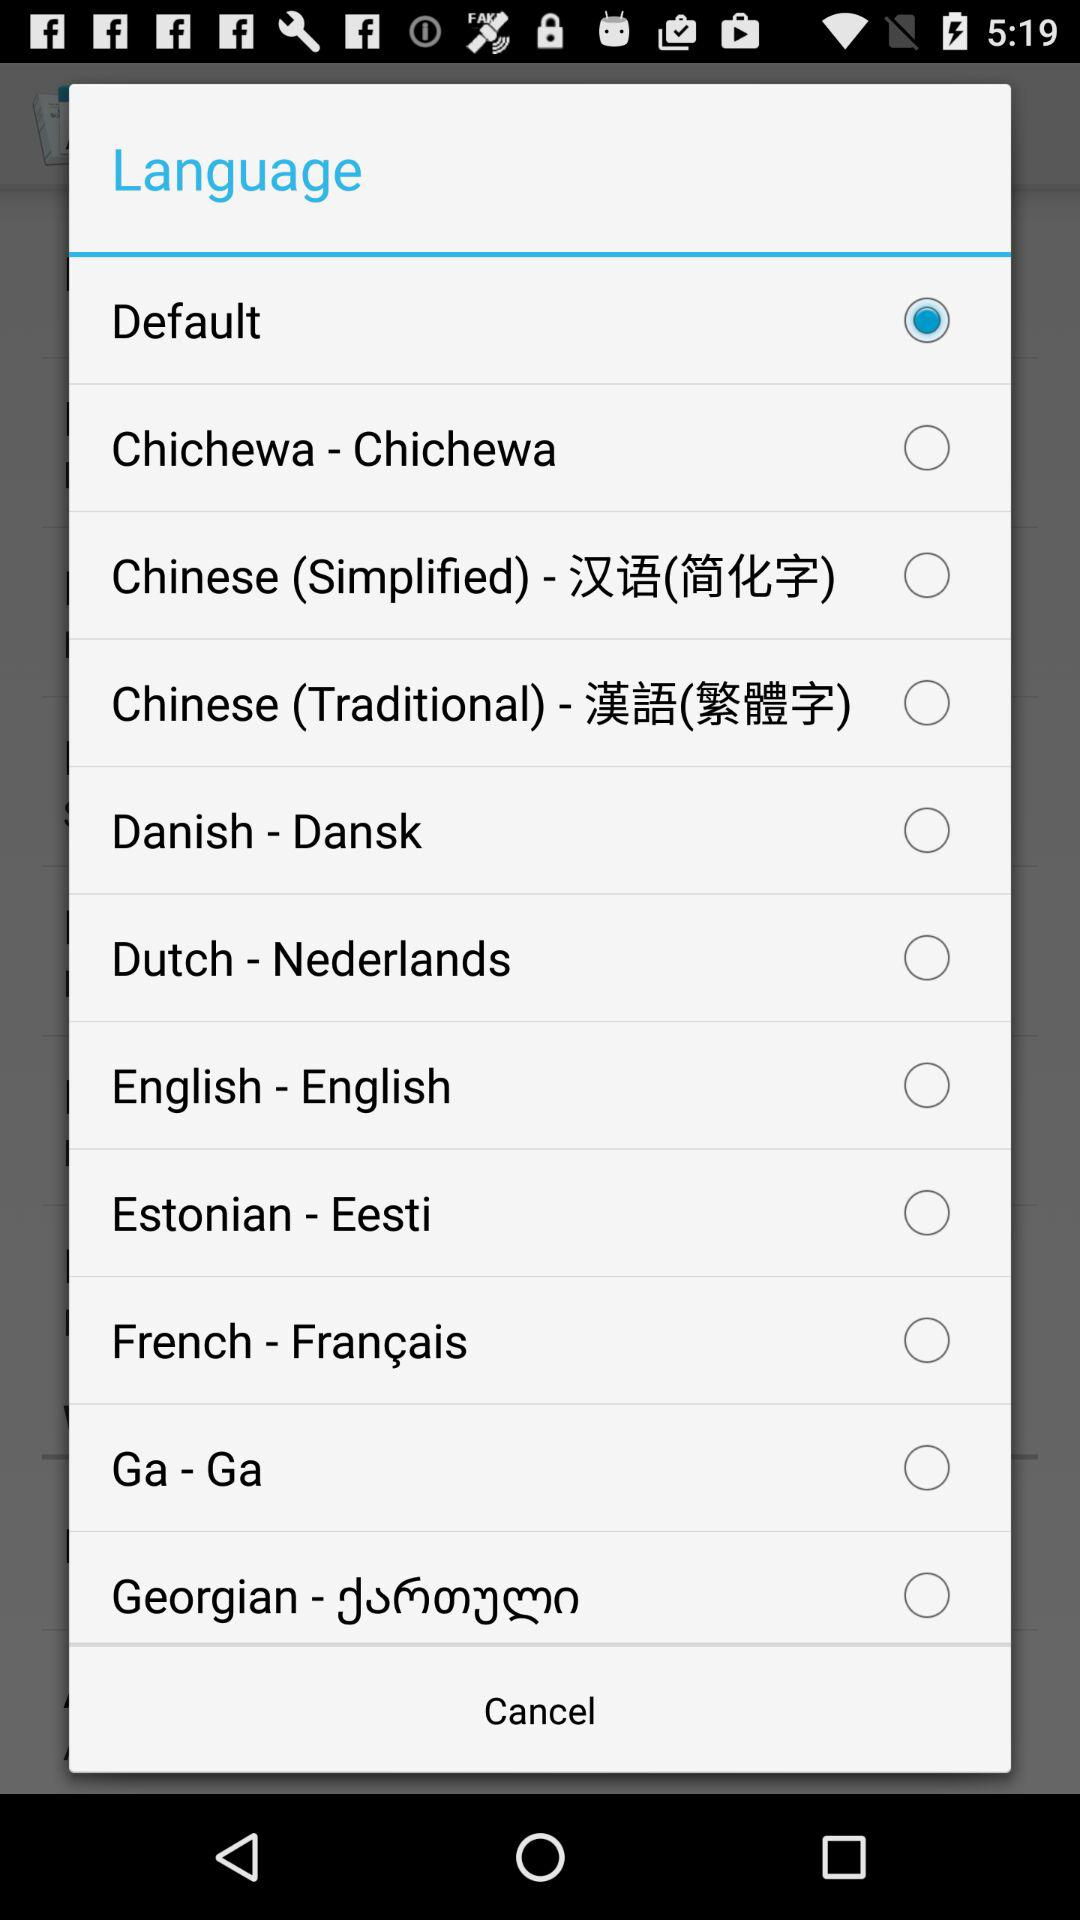Which option is selected? The selected option is "Default". 